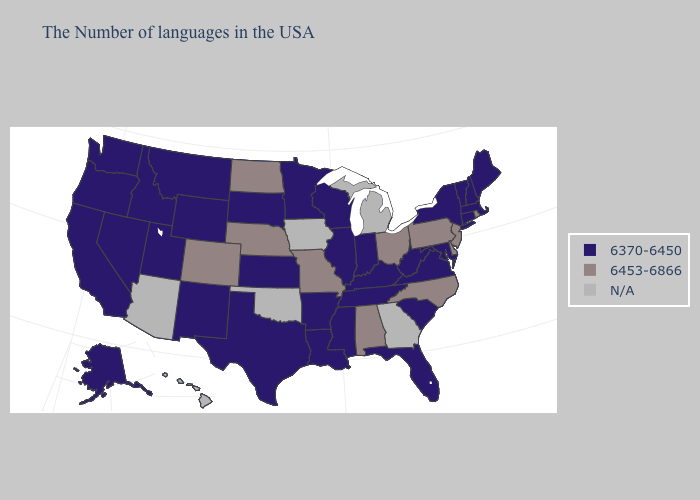What is the value of Oklahoma?
Short answer required. N/A. Name the states that have a value in the range 6370-6450?
Concise answer only. Maine, Massachusetts, New Hampshire, Vermont, Connecticut, New York, Maryland, Virginia, South Carolina, West Virginia, Florida, Kentucky, Indiana, Tennessee, Wisconsin, Illinois, Mississippi, Louisiana, Arkansas, Minnesota, Kansas, Texas, South Dakota, Wyoming, New Mexico, Utah, Montana, Idaho, Nevada, California, Washington, Oregon, Alaska. Name the states that have a value in the range 6453-6866?
Concise answer only. Rhode Island, New Jersey, Delaware, Pennsylvania, North Carolina, Ohio, Alabama, Missouri, Nebraska, North Dakota, Colorado. Does Ohio have the highest value in the USA?
Answer briefly. Yes. Name the states that have a value in the range 6370-6450?
Give a very brief answer. Maine, Massachusetts, New Hampshire, Vermont, Connecticut, New York, Maryland, Virginia, South Carolina, West Virginia, Florida, Kentucky, Indiana, Tennessee, Wisconsin, Illinois, Mississippi, Louisiana, Arkansas, Minnesota, Kansas, Texas, South Dakota, Wyoming, New Mexico, Utah, Montana, Idaho, Nevada, California, Washington, Oregon, Alaska. Does the first symbol in the legend represent the smallest category?
Give a very brief answer. Yes. Which states hav the highest value in the Northeast?
Quick response, please. Rhode Island, New Jersey, Pennsylvania. Among the states that border Kentucky , which have the highest value?
Short answer required. Ohio, Missouri. Does Pennsylvania have the lowest value in the USA?
Keep it brief. No. Does Florida have the highest value in the USA?
Give a very brief answer. No. Name the states that have a value in the range N/A?
Keep it brief. Georgia, Michigan, Iowa, Oklahoma, Arizona, Hawaii. Does Idaho have the highest value in the West?
Quick response, please. No. Is the legend a continuous bar?
Answer briefly. No. Does Utah have the lowest value in the USA?
Be succinct. Yes. Is the legend a continuous bar?
Be succinct. No. 